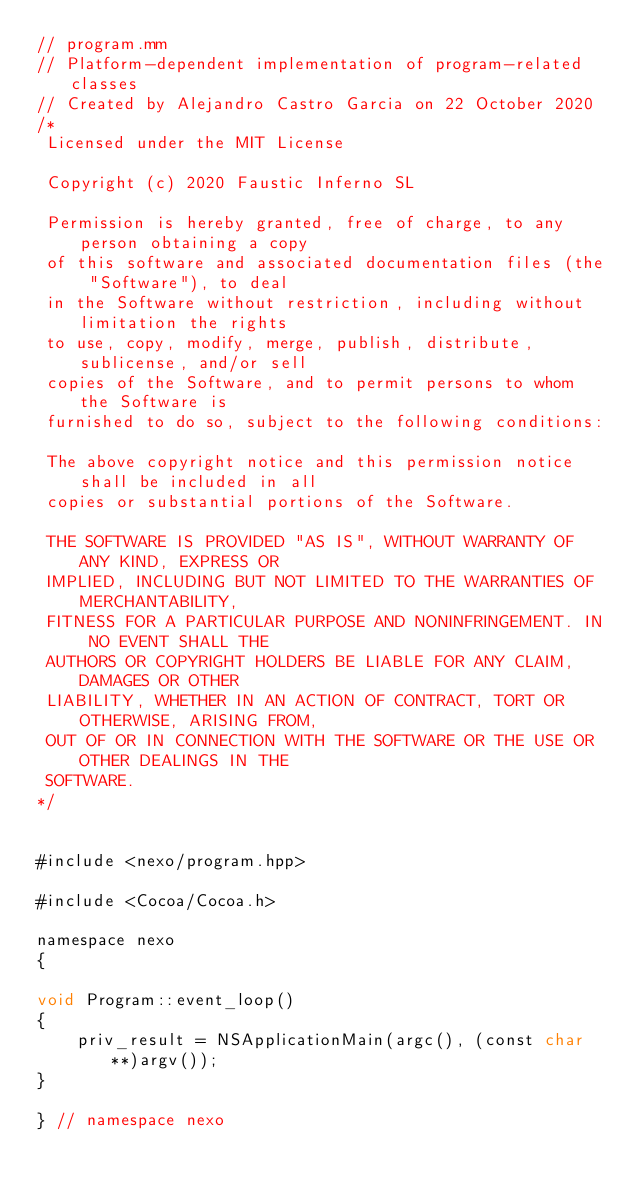Convert code to text. <code><loc_0><loc_0><loc_500><loc_500><_ObjectiveC_>// program.mm
// Platform-dependent implementation of program-related classes
// Created by Alejandro Castro Garcia on 22 October 2020
/*
 Licensed under the MIT License
 
 Copyright (c) 2020 Faustic Inferno SL
 
 Permission is hereby granted, free of charge, to any person obtaining a copy
 of this software and associated documentation files (the "Software"), to deal
 in the Software without restriction, including without limitation the rights
 to use, copy, modify, merge, publish, distribute, sublicense, and/or sell
 copies of the Software, and to permit persons to whom the Software is
 furnished to do so, subject to the following conditions:
 
 The above copyright notice and this permission notice shall be included in all
 copies or substantial portions of the Software.
 
 THE SOFTWARE IS PROVIDED "AS IS", WITHOUT WARRANTY OF ANY KIND, EXPRESS OR
 IMPLIED, INCLUDING BUT NOT LIMITED TO THE WARRANTIES OF MERCHANTABILITY,
 FITNESS FOR A PARTICULAR PURPOSE AND NONINFRINGEMENT. IN NO EVENT SHALL THE
 AUTHORS OR COPYRIGHT HOLDERS BE LIABLE FOR ANY CLAIM, DAMAGES OR OTHER
 LIABILITY, WHETHER IN AN ACTION OF CONTRACT, TORT OR OTHERWISE, ARISING FROM,
 OUT OF OR IN CONNECTION WITH THE SOFTWARE OR THE USE OR OTHER DEALINGS IN THE
 SOFTWARE.
*/


#include <nexo/program.hpp>

#include <Cocoa/Cocoa.h>

namespace nexo
{

void Program::event_loop()
{
    priv_result = NSApplicationMain(argc(), (const char**)argv());
}

} // namespace nexo
</code> 